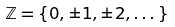<formula> <loc_0><loc_0><loc_500><loc_500>\mathbb { Z } = \{ 0 , \pm 1 , \pm 2 , \dots \}</formula> 